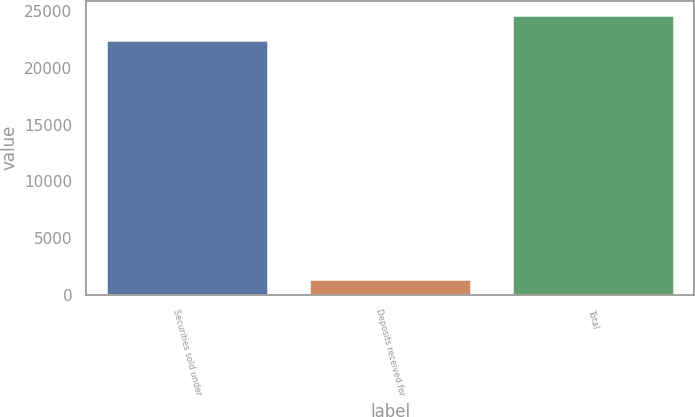Convert chart. <chart><loc_0><loc_0><loc_500><loc_500><bar_chart><fcel>Securities sold under<fcel>Deposits received for<fcel>Total<nl><fcel>22431<fcel>1414<fcel>24674.1<nl></chart> 